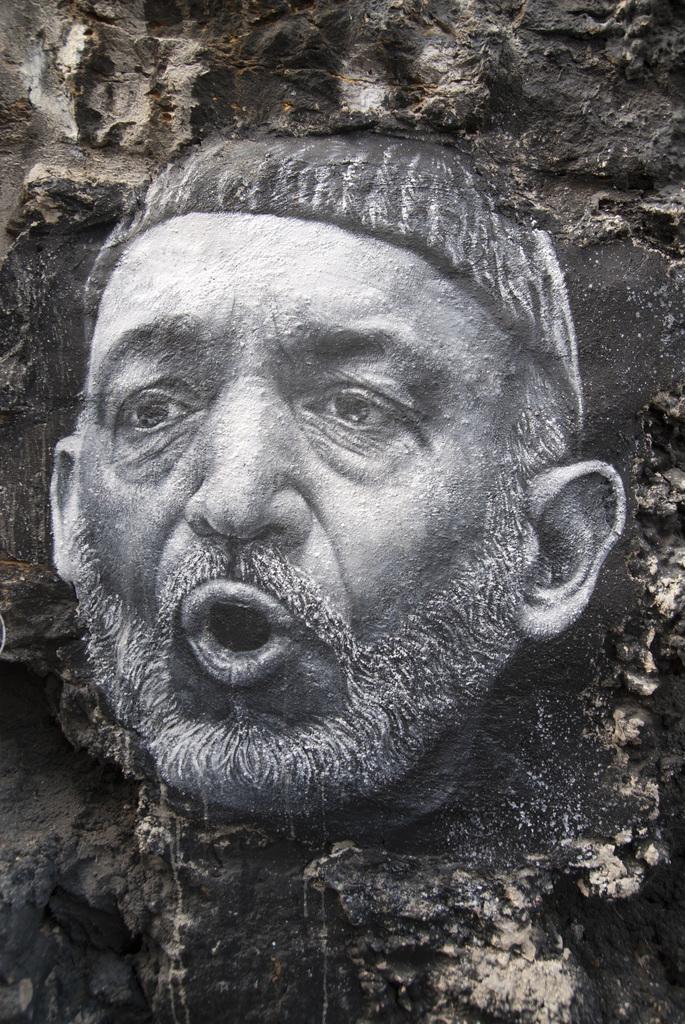Please provide a concise description of this image. In this image we can see a sculpture of a person's face on the wall. 